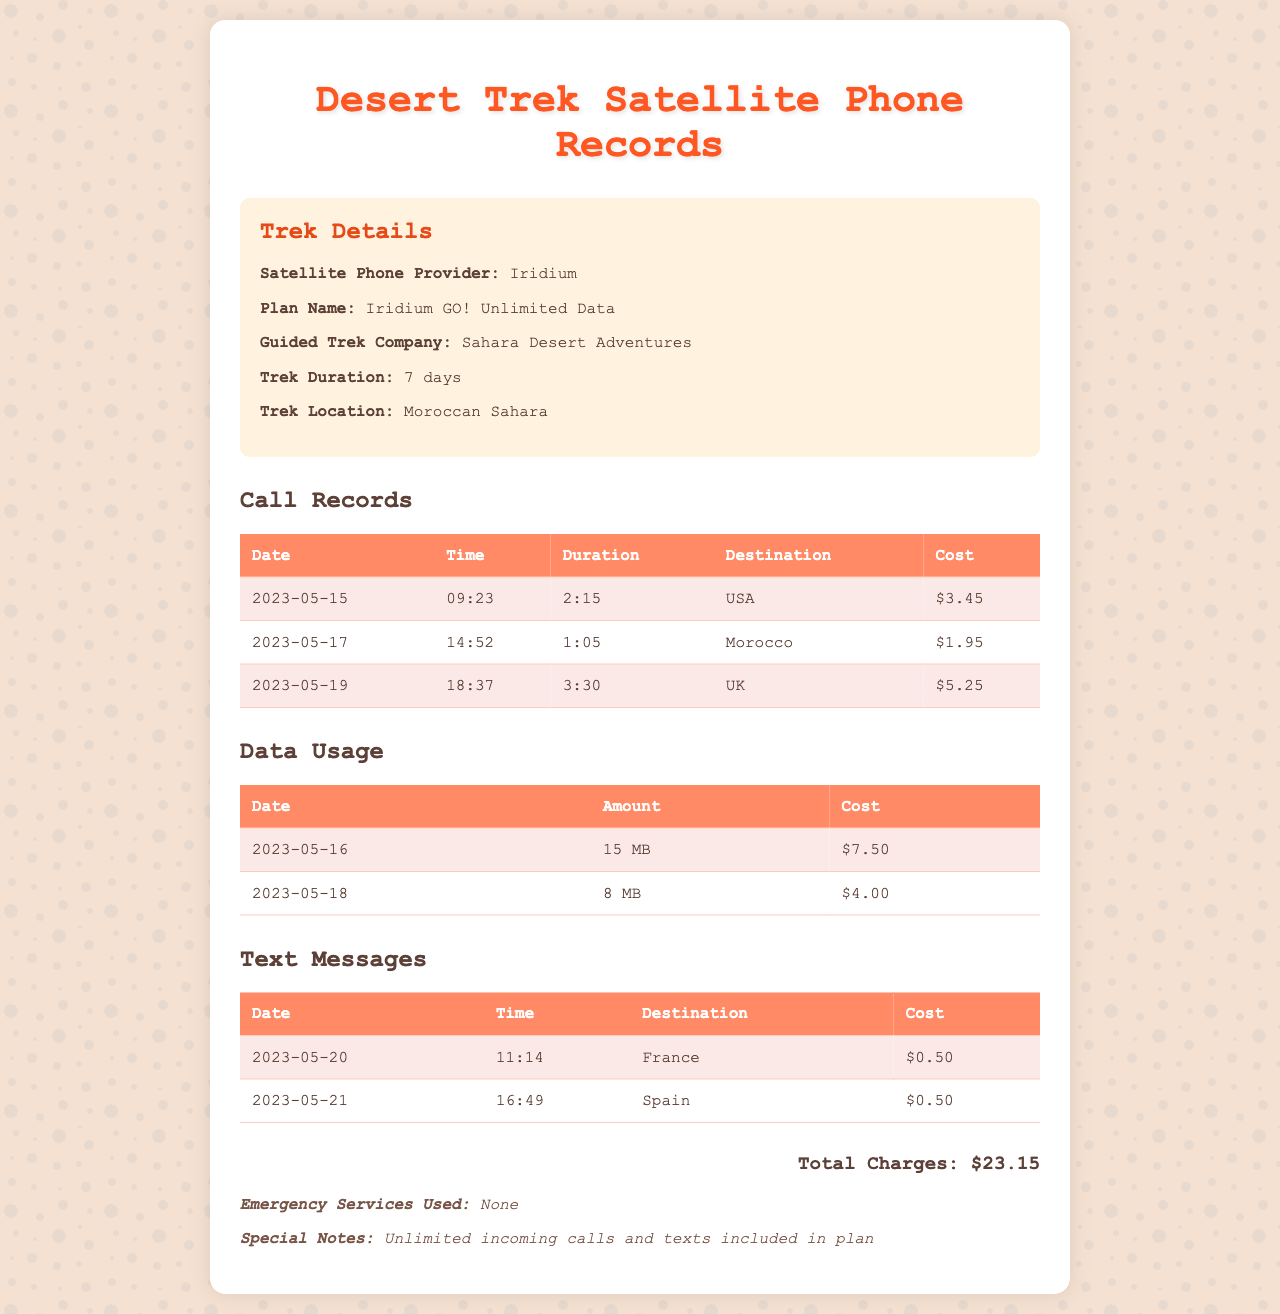what is the satellite phone provider? The satellite phone provider listed in the document is Iridium.
Answer: Iridium what is the total charges for the phone usage? The document summarizes the total charges incurred during the trek, which is the sum of call, data, and text message costs.
Answer: $23.15 how many text messages were recorded? The document shows a table of text messages, specifically listing two messages sent during the trek.
Answer: 2 when was the last call made? The last call recorded in the document occurred on May 19, 2023, at 18:37.
Answer: 2023-05-19 what was the duration of the first call? The first call made to the USA lasted for 2 hours and 15 minutes, as listed in the call records.
Answer: 2:15 which country did the data usage occur on May 16? The document lists data usage on May 16, but does not specify a country for that usage, as it only shows the amount consumed.
Answer: (not specified) what plan name was used for the satellite phone? The plan name mentioned in the document is Iridium GO! Unlimited Data.
Answer: Iridium GO! Unlimited Data what was the cost of the text message to France? The cost of the text message sent to France on May 20, 2023, is recorded in the document.
Answer: $0.50 which company guided the trek? The guided trek company mentioned in the document is Sahara Desert Adventures.
Answer: Sahara Desert Adventures 